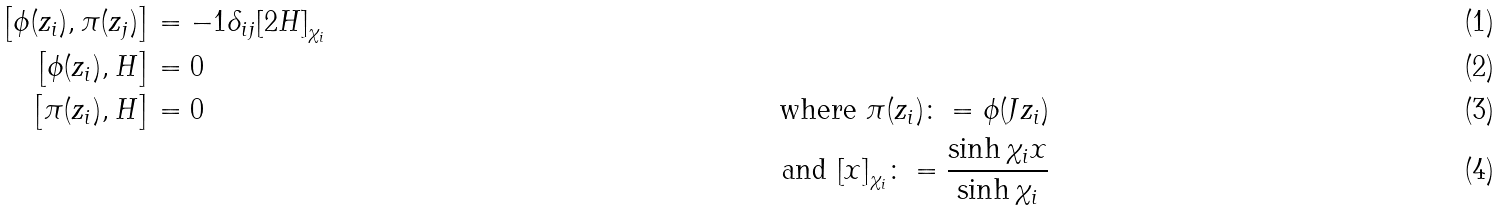Convert formula to latex. <formula><loc_0><loc_0><loc_500><loc_500>\left [ \phi ( { z } _ { i } ) , \pi ( { z } _ { j } ) \right ] & = - 1 { \delta } _ { i j } { \left [ 2 H \right ] } _ { { \chi } _ { i } } & \\ \left [ \phi ( { z } _ { i } ) , H \right ] & = 0 & \\ \left [ \pi ( { z } _ { i } ) , H \right ] & = 0 & \text { where $\pi({z}_{i}) \colon= \phi({J}{z}_{i})$} \\ & & \text { and ${\left[ x \right]}_{{\chi}_{i}} \colon= {\frac{\sinh{{\chi}_{i} x}} {\sinh{{\chi}_{i}}}}$}</formula> 